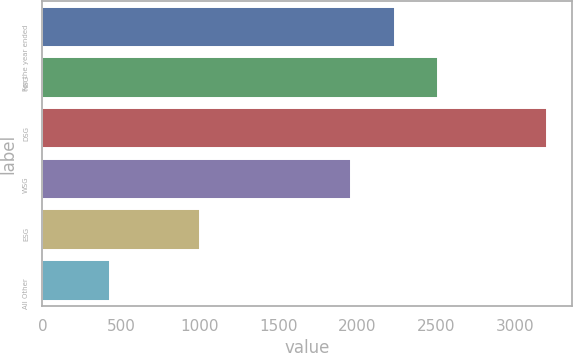<chart> <loc_0><loc_0><loc_500><loc_500><bar_chart><fcel>For the year ended<fcel>NSG<fcel>DSG<fcel>WSG<fcel>ESG<fcel>All Other<nl><fcel>2236.5<fcel>2514<fcel>3203<fcel>1959<fcel>1002<fcel>428<nl></chart> 